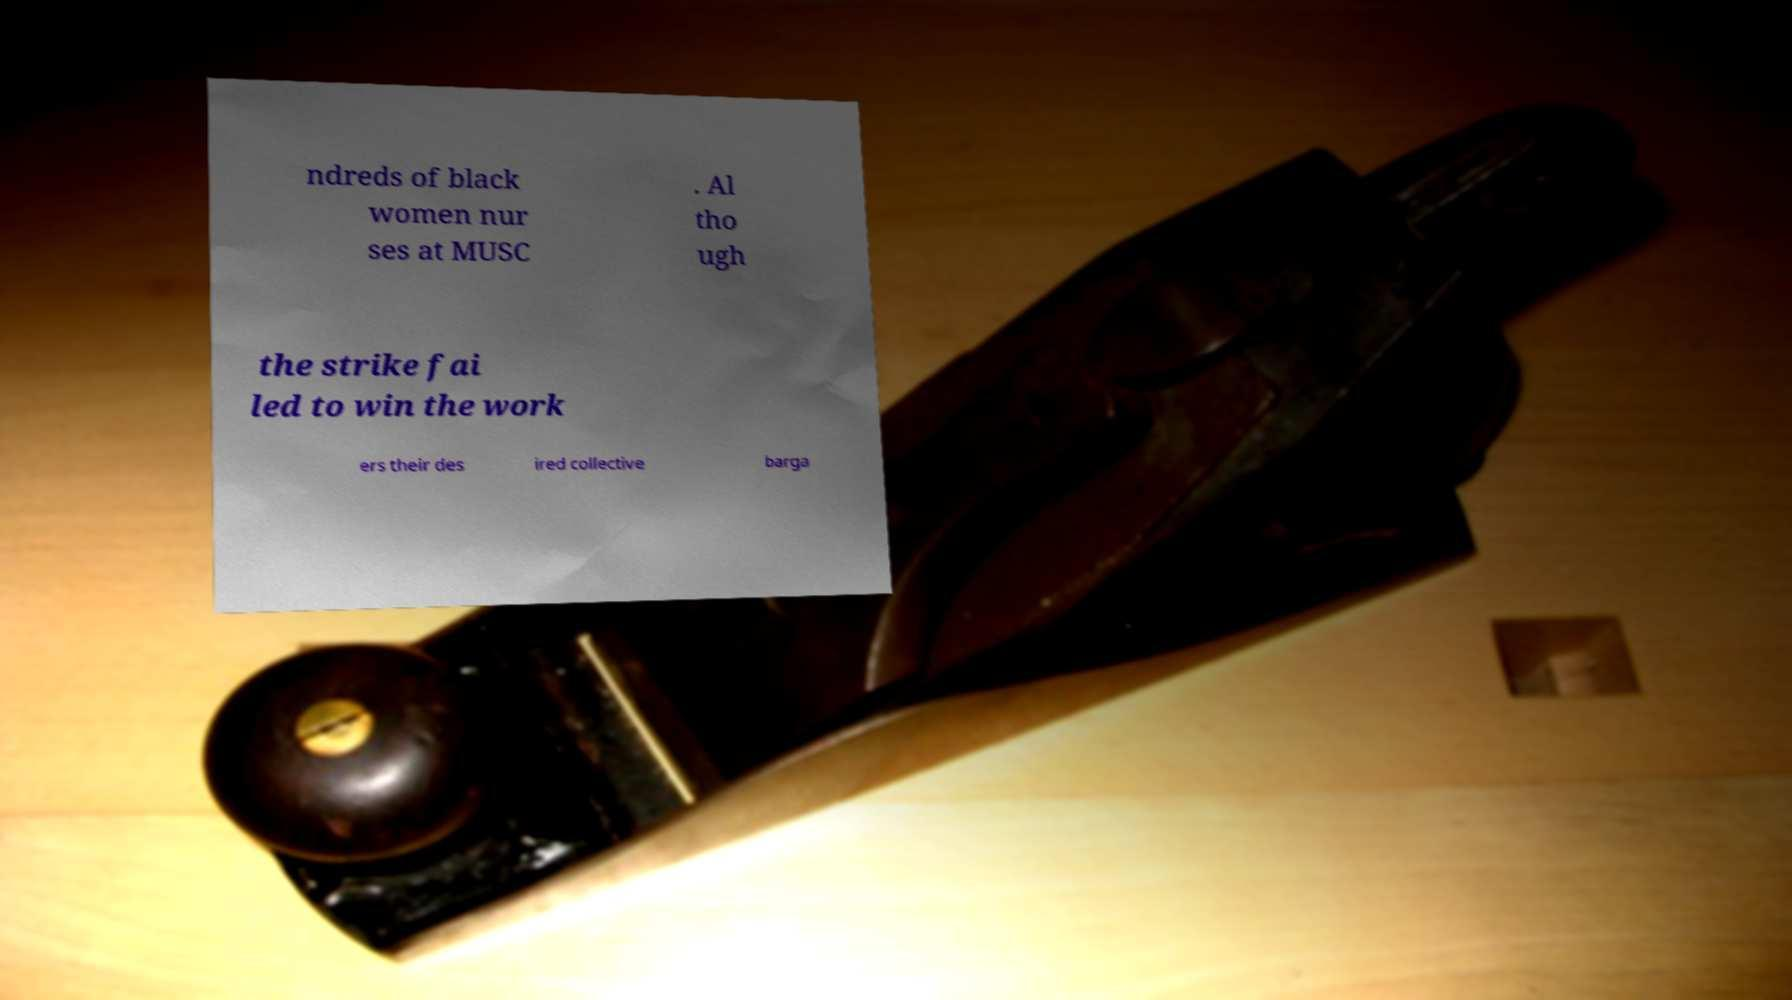For documentation purposes, I need the text within this image transcribed. Could you provide that? ndreds of black women nur ses at MUSC . Al tho ugh the strike fai led to win the work ers their des ired collective barga 